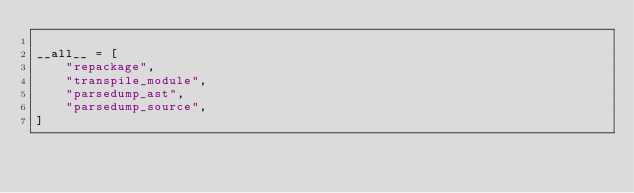Convert code to text. <code><loc_0><loc_0><loc_500><loc_500><_Python_>
__all__ = [
    "repackage",
    "transpile_module",
    "parsedump_ast",
    "parsedump_source",
]
</code> 